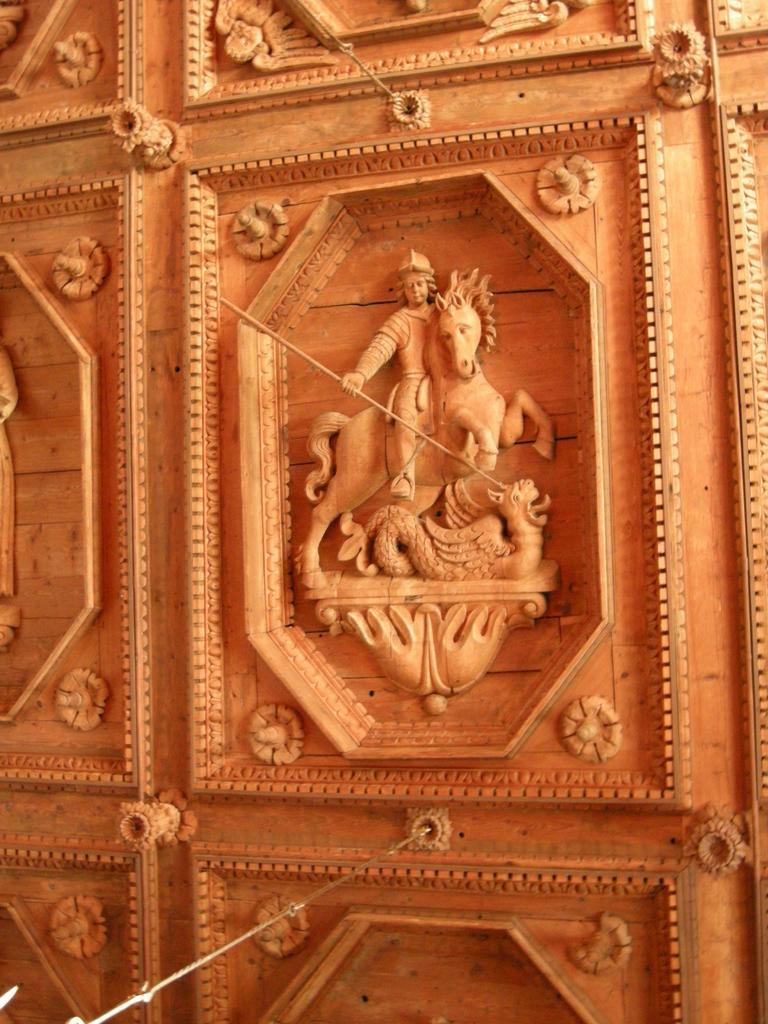In one or two sentences, can you explain what this image depicts? In this picture, we see a carved wooden door. 